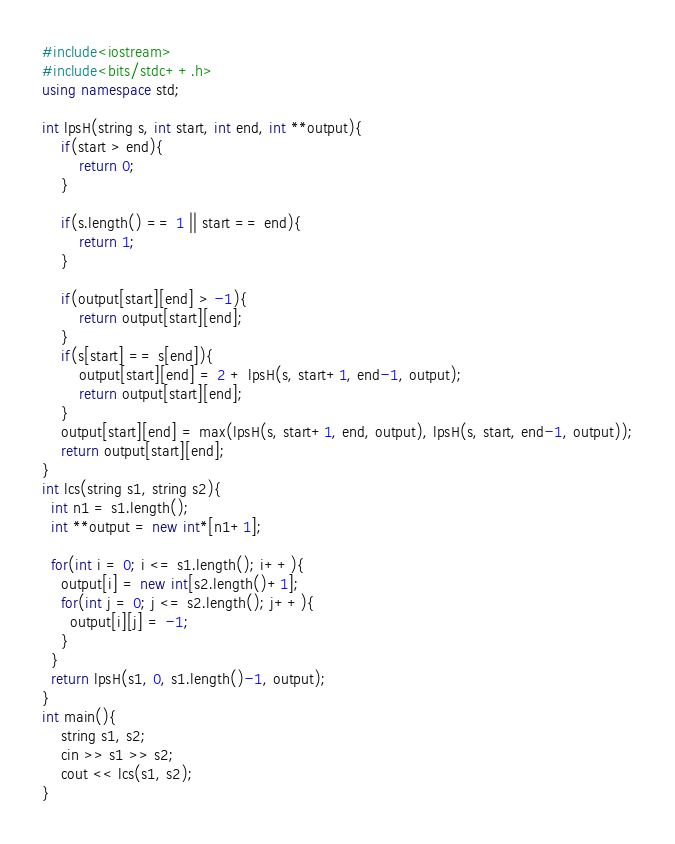Convert code to text. <code><loc_0><loc_0><loc_500><loc_500><_C++_>#include<iostream>
#include<bits/stdc++.h>
using namespace std;

int lpsH(string s, int start, int end, int **output){
	if(start > end){
		return 0;
	}

	if(s.length() == 1 || start == end){
		return 1;
	}
	
	if(output[start][end] > -1){
		return output[start][end];
	}
	if(s[start] == s[end]){
		output[start][end] = 2 + lpsH(s, start+1, end-1, output);
		return output[start][end];
	}
	output[start][end] = max(lpsH(s, start+1, end, output), lpsH(s, start, end-1, output));
	return output[start][end];
}
int lcs(string s1, string s2){
  int n1 = s1.length();
  int **output = new int*[n1+1];
  
  for(int i = 0; i <= s1.length(); i++){
    output[i] = new int[s2.length()+1];
    for(int j = 0; j <= s2.length(); j++){
      output[i][j] = -1;
    }
  }
  return lpsH(s1, 0, s1.length()-1, output);
}
int main(){
	string s1, s2;
	cin >> s1 >> s2;
	cout << lcs(s1, s2);
}
</code> 